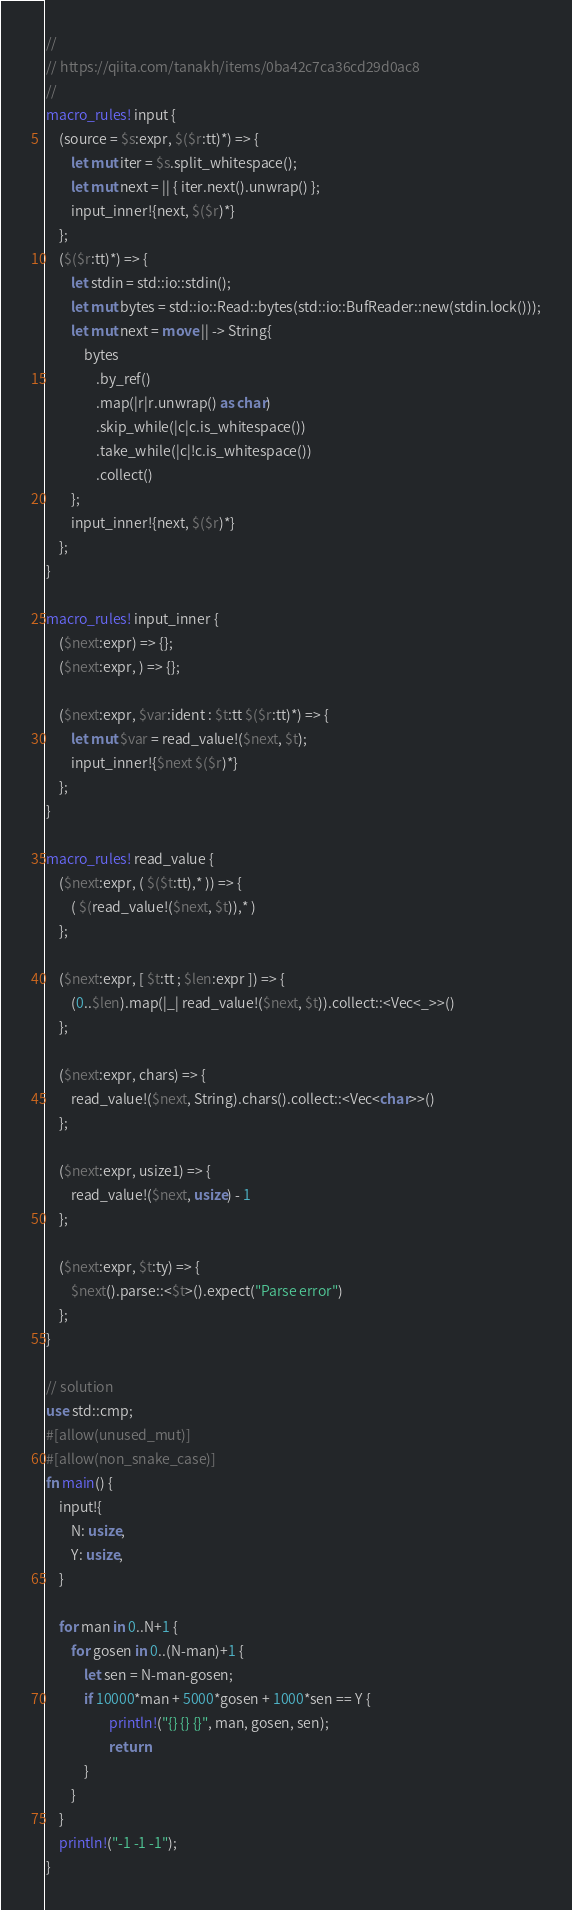<code> <loc_0><loc_0><loc_500><loc_500><_Rust_>//
// https://qiita.com/tanakh/items/0ba42c7ca36cd29d0ac8
//
macro_rules! input {
    (source = $s:expr, $($r:tt)*) => {
        let mut iter = $s.split_whitespace();
        let mut next = || { iter.next().unwrap() };
        input_inner!{next, $($r)*}
    };
    ($($r:tt)*) => {
        let stdin = std::io::stdin();
        let mut bytes = std::io::Read::bytes(std::io::BufReader::new(stdin.lock()));
        let mut next = move || -> String{
            bytes
                .by_ref()
                .map(|r|r.unwrap() as char)
                .skip_while(|c|c.is_whitespace())
                .take_while(|c|!c.is_whitespace())
                .collect()
        };
        input_inner!{next, $($r)*}
    };
}

macro_rules! input_inner {
    ($next:expr) => {};
    ($next:expr, ) => {};

    ($next:expr, $var:ident : $t:tt $($r:tt)*) => {
        let mut $var = read_value!($next, $t);
        input_inner!{$next $($r)*}
    };
}

macro_rules! read_value {
    ($next:expr, ( $($t:tt),* )) => {
        ( $(read_value!($next, $t)),* )
    };

    ($next:expr, [ $t:tt ; $len:expr ]) => {
        (0..$len).map(|_| read_value!($next, $t)).collect::<Vec<_>>()
    };

    ($next:expr, chars) => {
        read_value!($next, String).chars().collect::<Vec<char>>()
    };

    ($next:expr, usize1) => {
        read_value!($next, usize) - 1
    };

    ($next:expr, $t:ty) => {
        $next().parse::<$t>().expect("Parse error")
    };
}

// solution 
use std::cmp;
#[allow(unused_mut)]
#[allow(non_snake_case)]
fn main() {
    input!{
        N: usize,
        Y: usize,
    }

    for man in 0..N+1 {
        for gosen in 0..(N-man)+1 {
            let sen = N-man-gosen;
            if 10000*man + 5000*gosen + 1000*sen == Y {
                    println!("{} {} {}", man, gosen, sen);
                    return
            }
        }
    }
    println!("-1 -1 -1");
}
</code> 